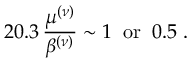Convert formula to latex. <formula><loc_0><loc_0><loc_500><loc_500>2 0 . 3 \, \frac { \mu ^ { ( \nu ) } } { \beta ^ { ( \nu ) } } \sim 1 \, o r \, 0 . 5 \, .</formula> 